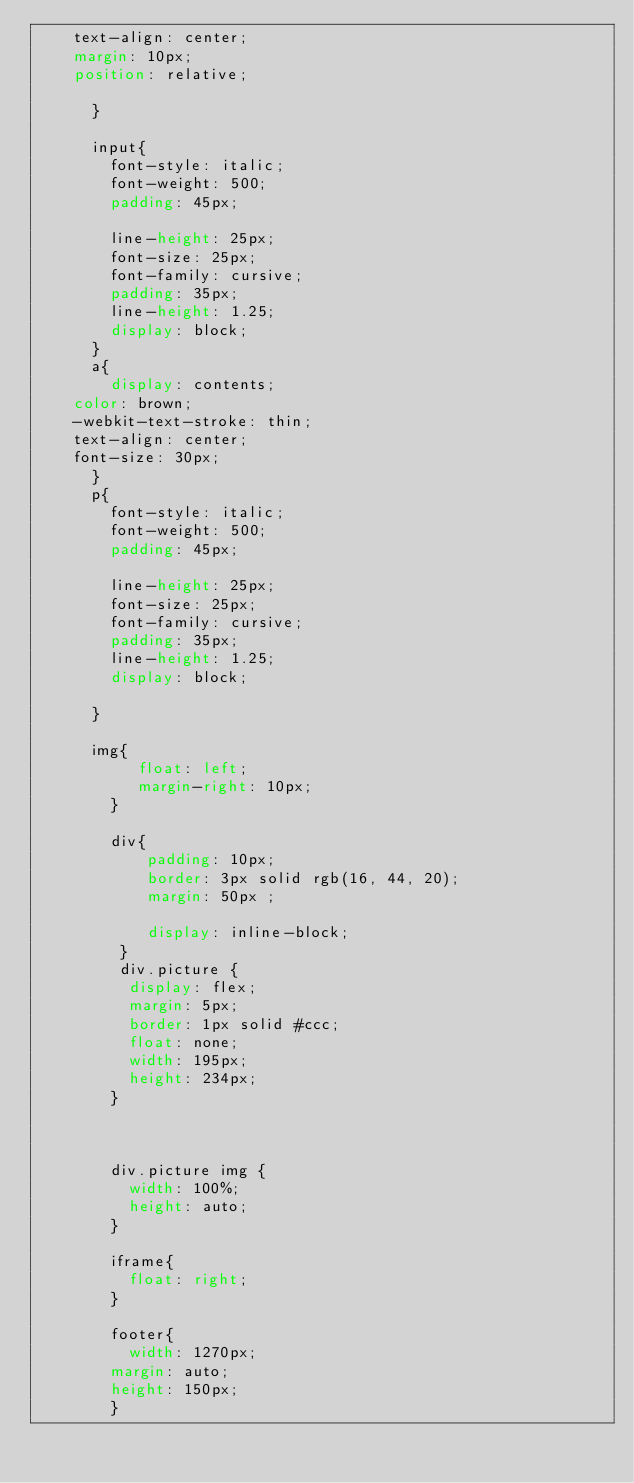<code> <loc_0><loc_0><loc_500><loc_500><_CSS_>    text-align: center;
    margin: 10px;
    position: relative;
     
      }

      input{
        font-style: italic;
        font-weight: 500;
        padding: 45px;
      
        line-height: 25px;
        font-size: 25px;
        font-family: cursive;
        padding: 35px;
        line-height: 1.25;
        display: block;
      }
      a{
        display: contents;
    color: brown;
    -webkit-text-stroke: thin;
    text-align: center;
    font-size: 30px;
      }
      p{
        font-style: italic;
        font-weight: 500;
        padding: 45px;
  
        line-height: 25px;
        font-size: 25px;
        font-family: cursive;
        padding: 35px;
        line-height: 1.25;
        display: block;
        
      }

      img{
           float: left; 
           margin-right: 10px;
        }
        
        div{
            padding: 10px;
            border: 3px solid rgb(16, 44, 20);
            margin: 50px ;
        
            display: inline-block;
         }
         div.picture {
          display: flex;
          margin: 5px;
          border: 1px solid #ccc;
          float: none;
          width: 195px;
          height: 234px;
        }
        
    
        
        div.picture img {
          width: 100%;
          height: auto;
        }
        
        iframe{
          float: right;
        }

        footer{
          width: 1270px;
        margin: auto;
        height: 150px;
        }

       
        
</code> 